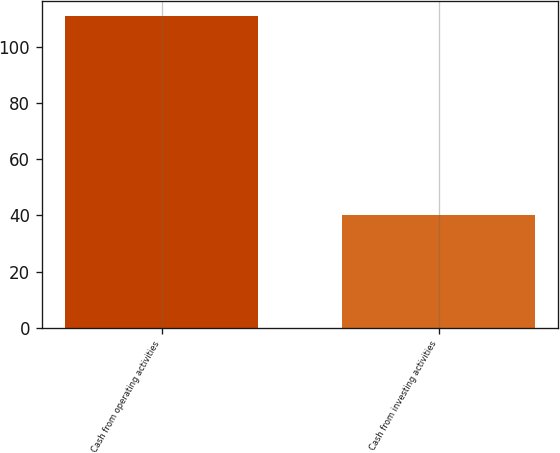Convert chart. <chart><loc_0><loc_0><loc_500><loc_500><bar_chart><fcel>Cash from operating activities<fcel>Cash from investing activities<nl><fcel>111<fcel>40<nl></chart> 